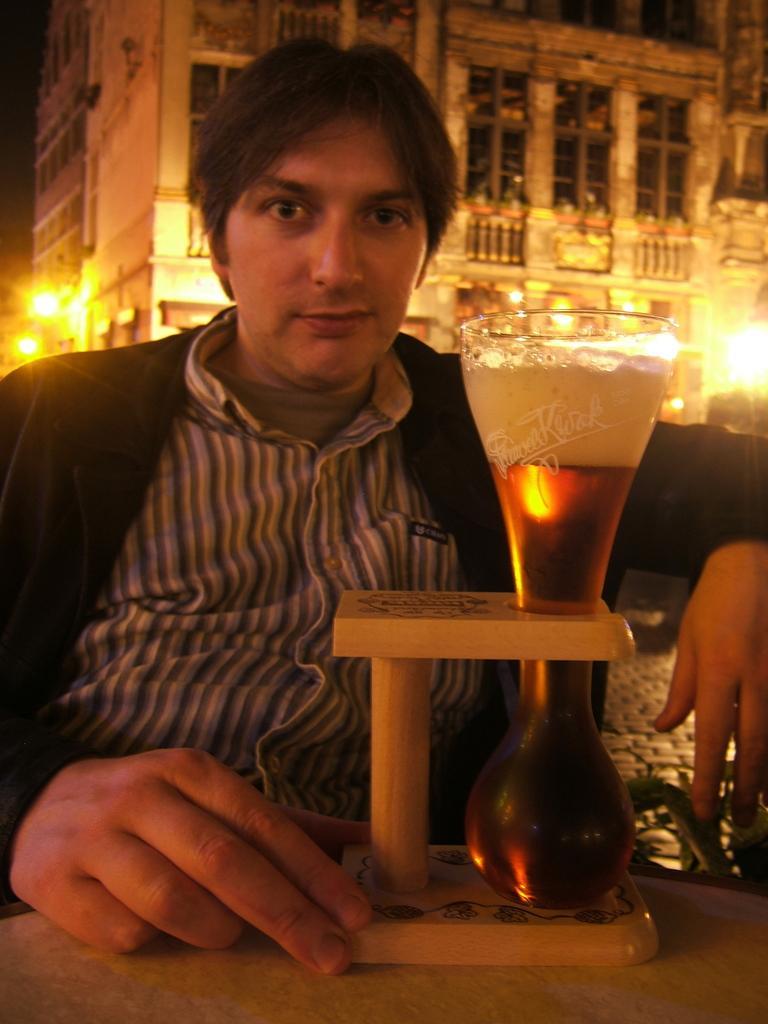Could you give a brief overview of what you see in this image? In this image there is a man sitting in the front and in front of the man there is a glass in the stand. In the background there is a building and there are lights hanging on the building. 